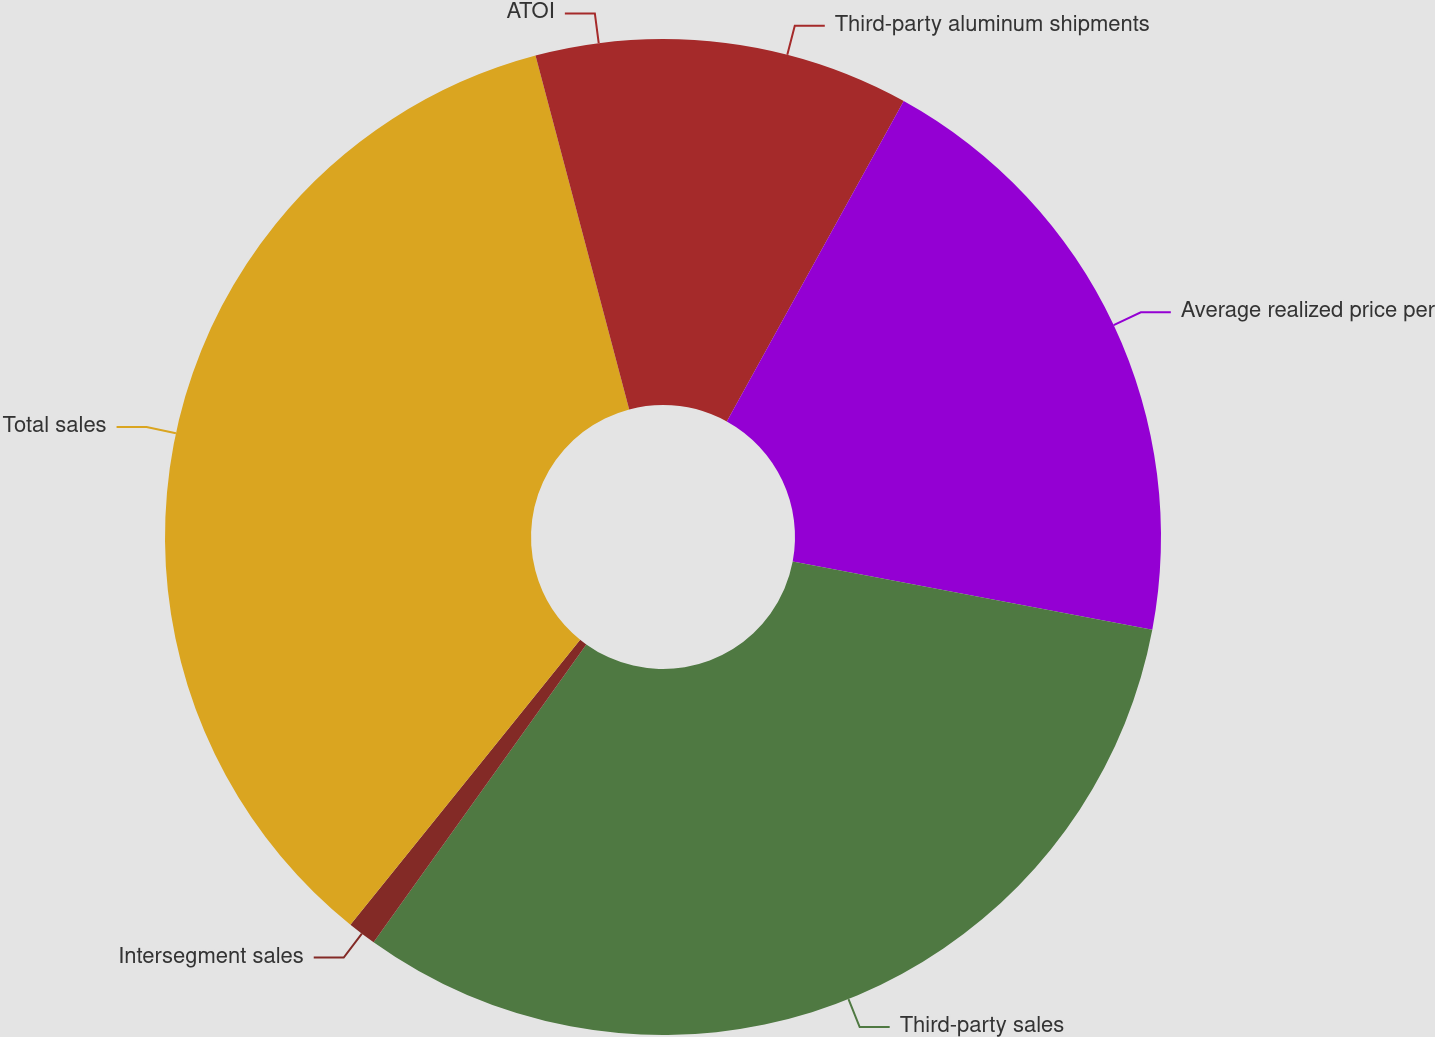<chart> <loc_0><loc_0><loc_500><loc_500><pie_chart><fcel>Third-party aluminum shipments<fcel>Average realized price per<fcel>Third-party sales<fcel>Intersegment sales<fcel>Total sales<fcel>ATOI<nl><fcel>8.03%<fcel>19.95%<fcel>31.89%<fcel>0.93%<fcel>35.08%<fcel>4.12%<nl></chart> 